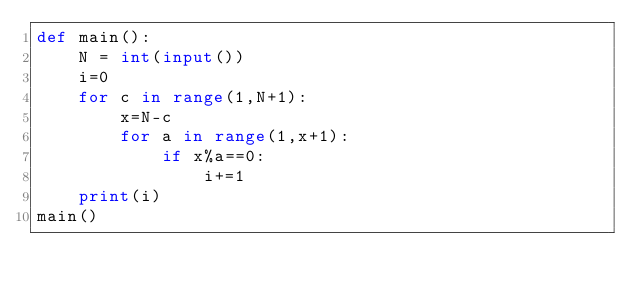Convert code to text. <code><loc_0><loc_0><loc_500><loc_500><_Python_>def main():
    N = int(input())
    i=0
    for c in range(1,N+1):
        x=N-c
        for a in range(1,x+1):
            if x%a==0:
                i+=1
    print(i)
main()</code> 